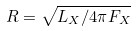<formula> <loc_0><loc_0><loc_500><loc_500>R = \sqrt { L _ { X } / 4 \pi F _ { X } }</formula> 